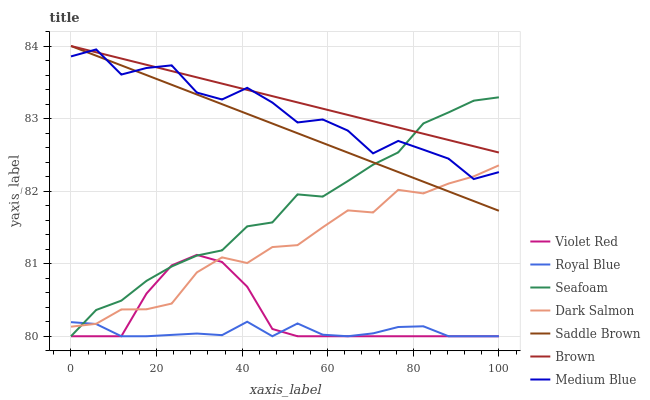Does Violet Red have the minimum area under the curve?
Answer yes or no. No. Does Violet Red have the maximum area under the curve?
Answer yes or no. No. Is Violet Red the smoothest?
Answer yes or no. No. Is Violet Red the roughest?
Answer yes or no. No. Does Medium Blue have the lowest value?
Answer yes or no. No. Does Violet Red have the highest value?
Answer yes or no. No. Is Violet Red less than Saddle Brown?
Answer yes or no. Yes. Is Brown greater than Royal Blue?
Answer yes or no. Yes. Does Violet Red intersect Saddle Brown?
Answer yes or no. No. 